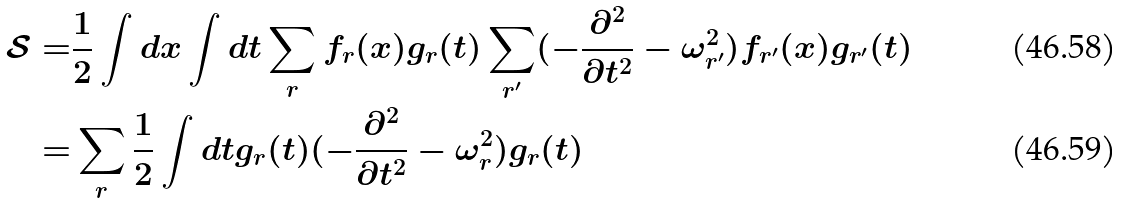<formula> <loc_0><loc_0><loc_500><loc_500>\mathcal { S } = & \frac { 1 } { 2 } \int d x \int d t \sum _ { r } f _ { r } ( x ) g _ { r } ( t ) \sum _ { r ^ { \prime } } ( - \frac { \partial ^ { 2 } } { \partial t ^ { 2 } } - \omega _ { r ^ { \prime } } ^ { 2 } ) f _ { r ^ { \prime } } ( x ) g _ { r ^ { \prime } } ( t ) \\ = & \sum _ { r } \frac { 1 } { 2 } \int d t g _ { r } ( t ) ( - \frac { \partial ^ { 2 } } { \partial t ^ { 2 } } - \omega _ { r } ^ { 2 } ) g _ { r } ( t )</formula> 